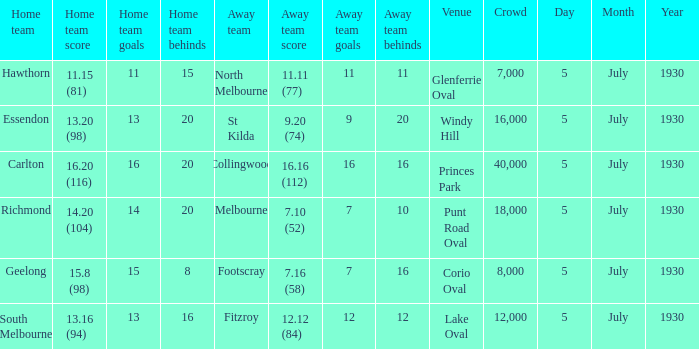Can you parse all the data within this table? {'header': ['Home team', 'Home team score', 'Home team goals', 'Home team behinds', 'Away team', 'Away team score', 'Away team goals', 'Away team behinds', 'Venue', 'Crowd', 'Day', 'Month', 'Year'], 'rows': [['Hawthorn', '11.15 (81)', '11', '15', 'North Melbourne', '11.11 (77)', '11', '11', 'Glenferrie Oval', '7,000', '5', 'July', '1930'], ['Essendon', '13.20 (98)', '13', '20', 'St Kilda', '9.20 (74)', '9', '20', 'Windy Hill', '16,000', '5', 'July', '1930'], ['Carlton', '16.20 (116)', '16', '20', 'Collingwood', '16.16 (112)', '16', '16', 'Princes Park', '40,000', '5', 'July', '1930'], ['Richmond', '14.20 (104)', '14', '20', 'Melbourne', '7.10 (52)', '7', '10', 'Punt Road Oval', '18,000', '5', 'July', '1930'], ['Geelong', '15.8 (98)', '15', '8', 'Footscray', '7.16 (58)', '7', '16', 'Corio Oval', '8,000', '5', 'July', '1930'], ['South Melbourne', '13.16 (94)', '13', '16', 'Fitzroy', '12.12 (84)', '12', '12', 'Lake Oval', '12,000', '5', 'July', '1930']]} What day does the team play at punt road oval? 5 July 1930. 